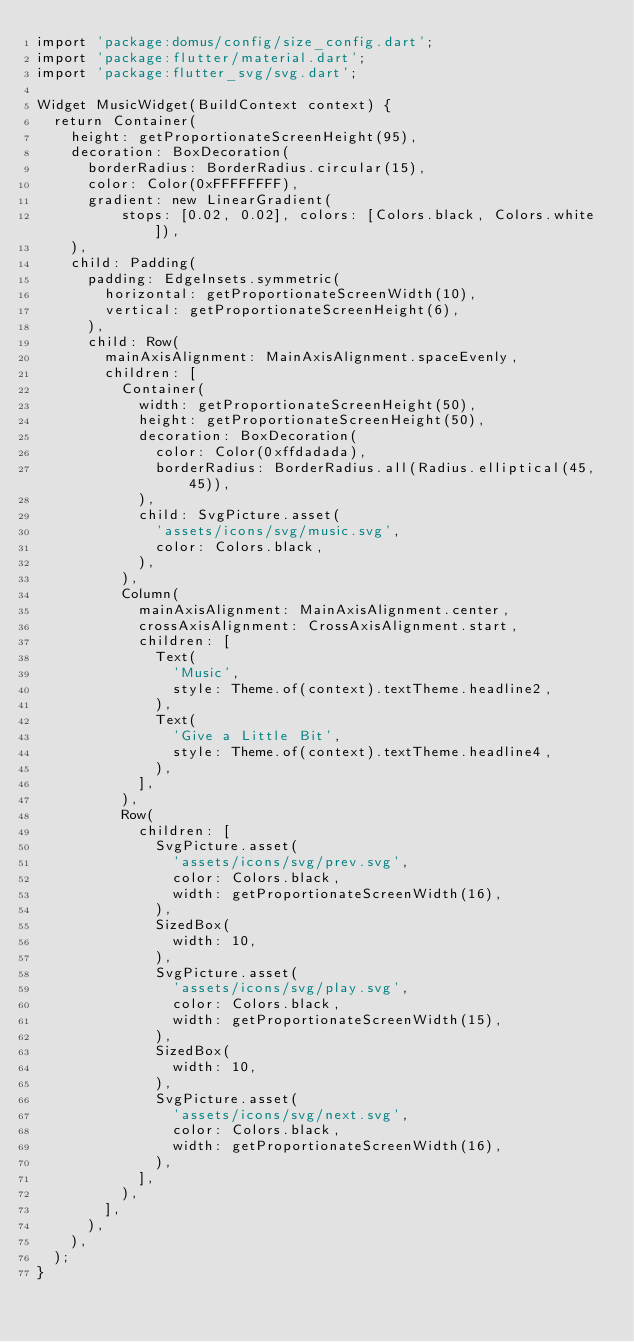Convert code to text. <code><loc_0><loc_0><loc_500><loc_500><_Dart_>import 'package:domus/config/size_config.dart';
import 'package:flutter/material.dart';
import 'package:flutter_svg/svg.dart';

Widget MusicWidget(BuildContext context) {
  return Container(
    height: getProportionateScreenHeight(95),
    decoration: BoxDecoration(
      borderRadius: BorderRadius.circular(15),
      color: Color(0xFFFFFFFF),
      gradient: new LinearGradient(
          stops: [0.02, 0.02], colors: [Colors.black, Colors.white]),
    ),
    child: Padding(
      padding: EdgeInsets.symmetric(
        horizontal: getProportionateScreenWidth(10),
        vertical: getProportionateScreenHeight(6),
      ),
      child: Row(
        mainAxisAlignment: MainAxisAlignment.spaceEvenly,
        children: [
          Container(
            width: getProportionateScreenHeight(50),
            height: getProportionateScreenHeight(50),
            decoration: BoxDecoration(
              color: Color(0xffdadada),
              borderRadius: BorderRadius.all(Radius.elliptical(45, 45)),
            ),
            child: SvgPicture.asset(
              'assets/icons/svg/music.svg',
              color: Colors.black,
            ),
          ),
          Column(
            mainAxisAlignment: MainAxisAlignment.center,
            crossAxisAlignment: CrossAxisAlignment.start,
            children: [
              Text(
                'Music',
                style: Theme.of(context).textTheme.headline2,
              ),
              Text(
                'Give a Little Bit',
                style: Theme.of(context).textTheme.headline4,
              ),
            ],
          ),
          Row(
            children: [
              SvgPicture.asset(
                'assets/icons/svg/prev.svg',
                color: Colors.black,
                width: getProportionateScreenWidth(16),
              ),
              SizedBox(
                width: 10,
              ),
              SvgPicture.asset(
                'assets/icons/svg/play.svg',
                color: Colors.black,
                width: getProportionateScreenWidth(15),
              ),
              SizedBox(
                width: 10,
              ),
              SvgPicture.asset(
                'assets/icons/svg/next.svg',
                color: Colors.black,
                width: getProportionateScreenWidth(16),
              ),
            ],
          ),
        ],
      ),
    ),
  );
}
</code> 